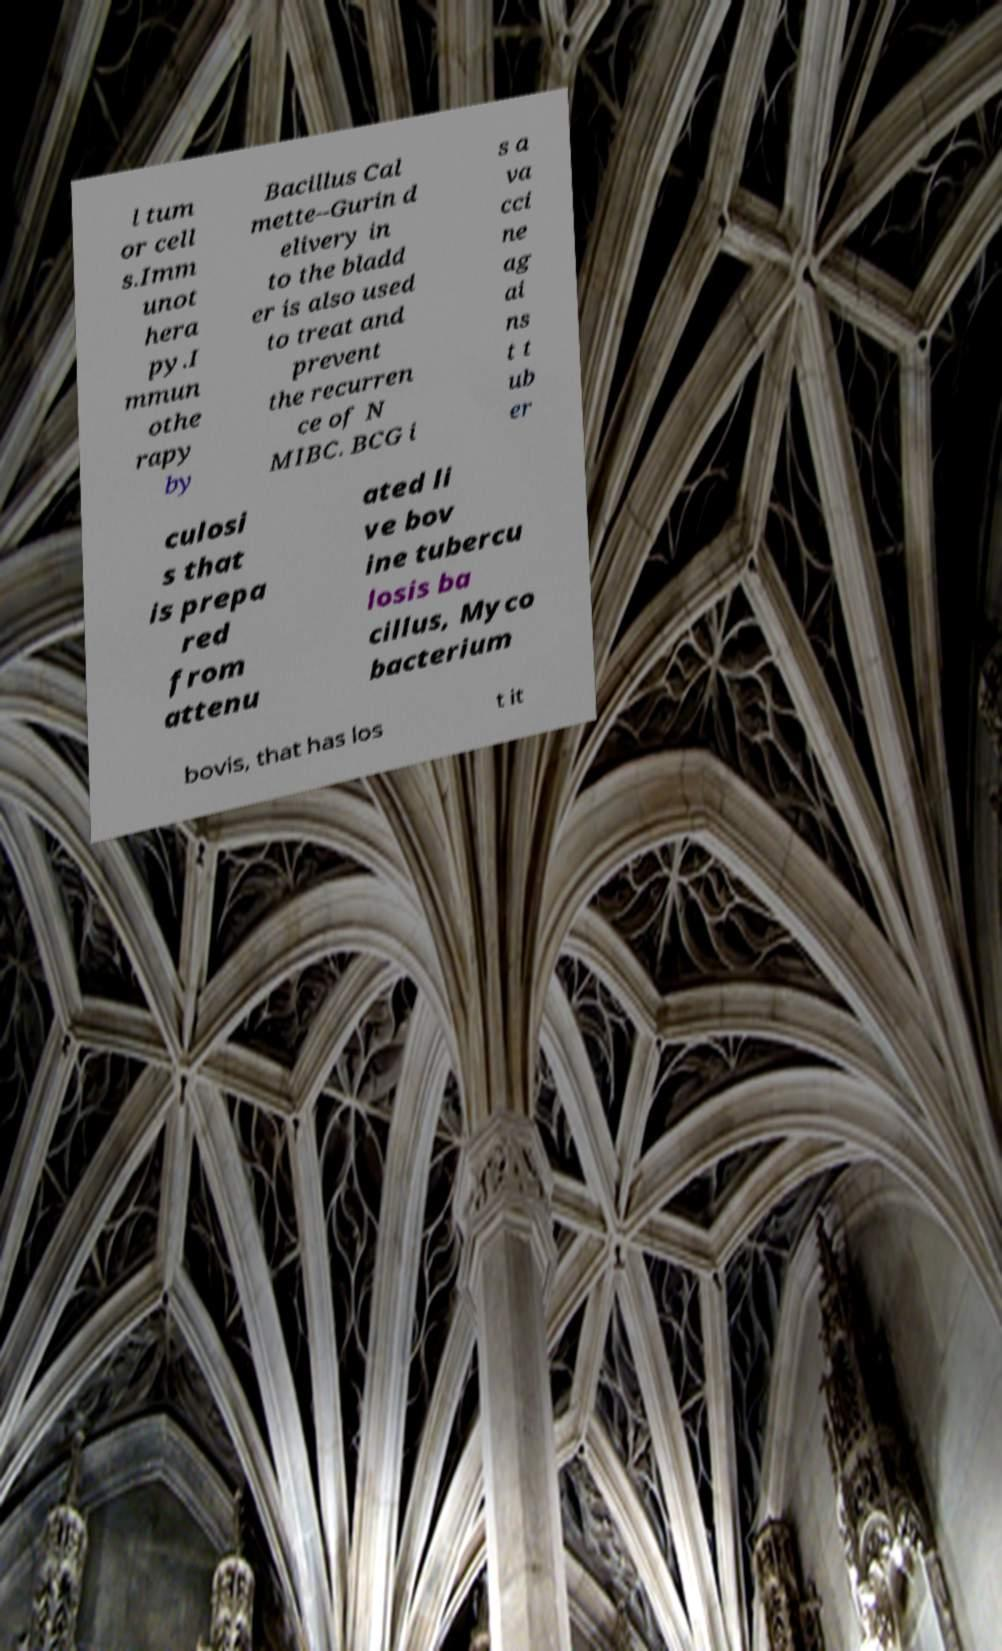There's text embedded in this image that I need extracted. Can you transcribe it verbatim? l tum or cell s.Imm unot hera py.I mmun othe rapy by Bacillus Cal mette–Gurin d elivery in to the bladd er is also used to treat and prevent the recurren ce of N MIBC. BCG i s a va cci ne ag ai ns t t ub er culosi s that is prepa red from attenu ated li ve bov ine tubercu losis ba cillus, Myco bacterium bovis, that has los t it 